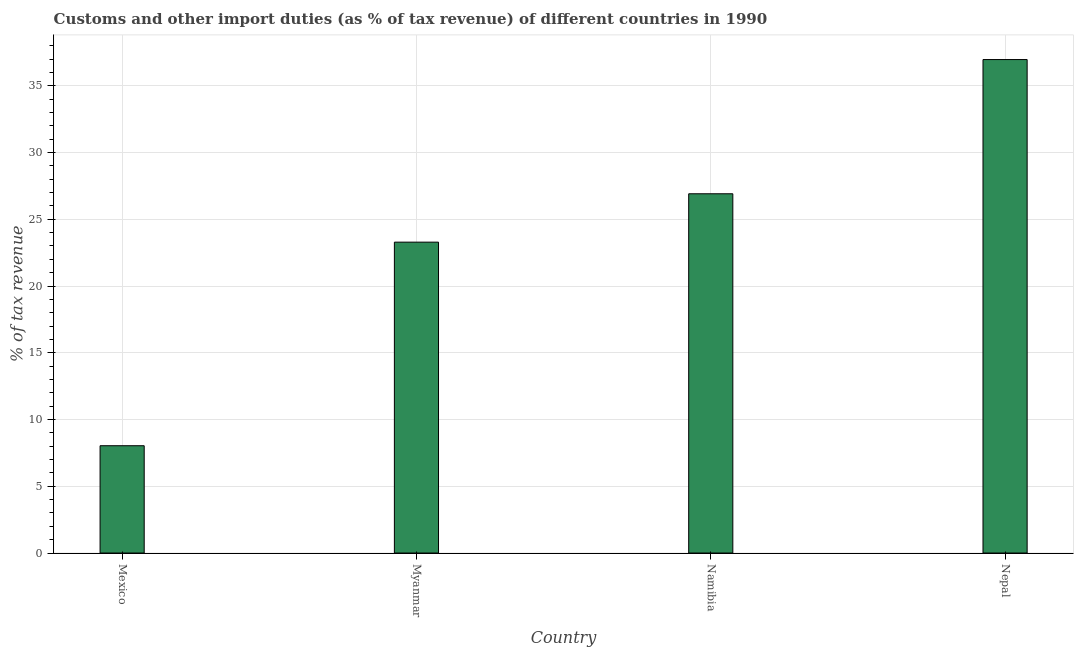Does the graph contain grids?
Ensure brevity in your answer.  Yes. What is the title of the graph?
Your answer should be compact. Customs and other import duties (as % of tax revenue) of different countries in 1990. What is the label or title of the Y-axis?
Ensure brevity in your answer.  % of tax revenue. What is the customs and other import duties in Namibia?
Your answer should be very brief. 26.91. Across all countries, what is the maximum customs and other import duties?
Your answer should be very brief. 36.97. Across all countries, what is the minimum customs and other import duties?
Your response must be concise. 8.04. In which country was the customs and other import duties maximum?
Keep it short and to the point. Nepal. What is the sum of the customs and other import duties?
Make the answer very short. 95.2. What is the difference between the customs and other import duties in Mexico and Myanmar?
Provide a short and direct response. -15.25. What is the average customs and other import duties per country?
Provide a short and direct response. 23.8. What is the median customs and other import duties?
Your answer should be compact. 25.1. In how many countries, is the customs and other import duties greater than 32 %?
Offer a very short reply. 1. What is the ratio of the customs and other import duties in Mexico to that in Myanmar?
Provide a succinct answer. 0.34. Is the customs and other import duties in Myanmar less than that in Nepal?
Ensure brevity in your answer.  Yes. Is the difference between the customs and other import duties in Mexico and Namibia greater than the difference between any two countries?
Your answer should be compact. No. What is the difference between the highest and the second highest customs and other import duties?
Make the answer very short. 10.05. What is the difference between the highest and the lowest customs and other import duties?
Ensure brevity in your answer.  28.93. In how many countries, is the customs and other import duties greater than the average customs and other import duties taken over all countries?
Provide a succinct answer. 2. Are all the bars in the graph horizontal?
Provide a short and direct response. No. What is the difference between two consecutive major ticks on the Y-axis?
Offer a very short reply. 5. What is the % of tax revenue in Mexico?
Keep it short and to the point. 8.04. What is the % of tax revenue in Myanmar?
Ensure brevity in your answer.  23.29. What is the % of tax revenue in Namibia?
Your response must be concise. 26.91. What is the % of tax revenue of Nepal?
Give a very brief answer. 36.97. What is the difference between the % of tax revenue in Mexico and Myanmar?
Make the answer very short. -15.25. What is the difference between the % of tax revenue in Mexico and Namibia?
Make the answer very short. -18.87. What is the difference between the % of tax revenue in Mexico and Nepal?
Your response must be concise. -28.93. What is the difference between the % of tax revenue in Myanmar and Namibia?
Your answer should be compact. -3.62. What is the difference between the % of tax revenue in Myanmar and Nepal?
Give a very brief answer. -13.68. What is the difference between the % of tax revenue in Namibia and Nepal?
Provide a short and direct response. -10.06. What is the ratio of the % of tax revenue in Mexico to that in Myanmar?
Offer a very short reply. 0.34. What is the ratio of the % of tax revenue in Mexico to that in Namibia?
Keep it short and to the point. 0.3. What is the ratio of the % of tax revenue in Mexico to that in Nepal?
Your answer should be very brief. 0.22. What is the ratio of the % of tax revenue in Myanmar to that in Namibia?
Offer a terse response. 0.86. What is the ratio of the % of tax revenue in Myanmar to that in Nepal?
Offer a terse response. 0.63. What is the ratio of the % of tax revenue in Namibia to that in Nepal?
Your answer should be compact. 0.73. 